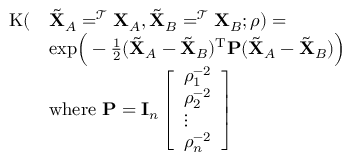<formula> <loc_0><loc_0><loc_500><loc_500>\begin{array} { r l } { K ( } & { \tilde { X } _ { A } = ^ { \mathcal { T } } X _ { A } , \tilde { X } _ { B } = ^ { \mathcal { T } } X _ { B } ; \rho ) = } \\ & { e x p \left ( - \frac { 1 } { 2 } ( \tilde { X } _ { A } - \tilde { X } _ { B } ) ^ { T } P ( \tilde { X } _ { A } - \tilde { X } _ { B } ) \right ) } \\ & { w h e r e \ P = I _ { n } \left [ \begin{array} { l } { \rho _ { 1 } ^ { - 2 } } \\ { \rho _ { 2 } ^ { - 2 } } \\ { \vdots } \\ { \rho _ { n } ^ { - 2 } } \end{array} \right ] } \end{array}</formula> 